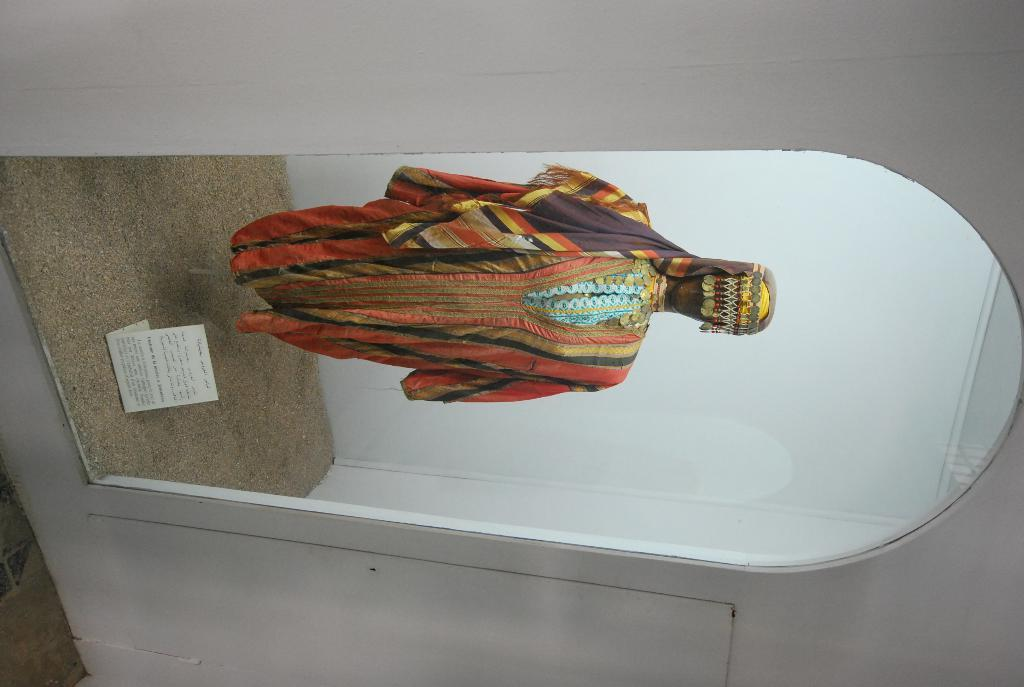What is the main subject of the image? There is a statue in the image. What is the statue wearing? The statue is wearing a colorful cloth dress. How is the statue displayed in the image? The statue is placed in a mirror box. What type of surface can be seen in the image? There is sand visible in the image. What type of informational material is present in the image? There is a paper brochure in the image. What type of gun is visible in the image? There is no gun present in the image; it features a statue wearing a colorful cloth dress and placed in a mirror box. 